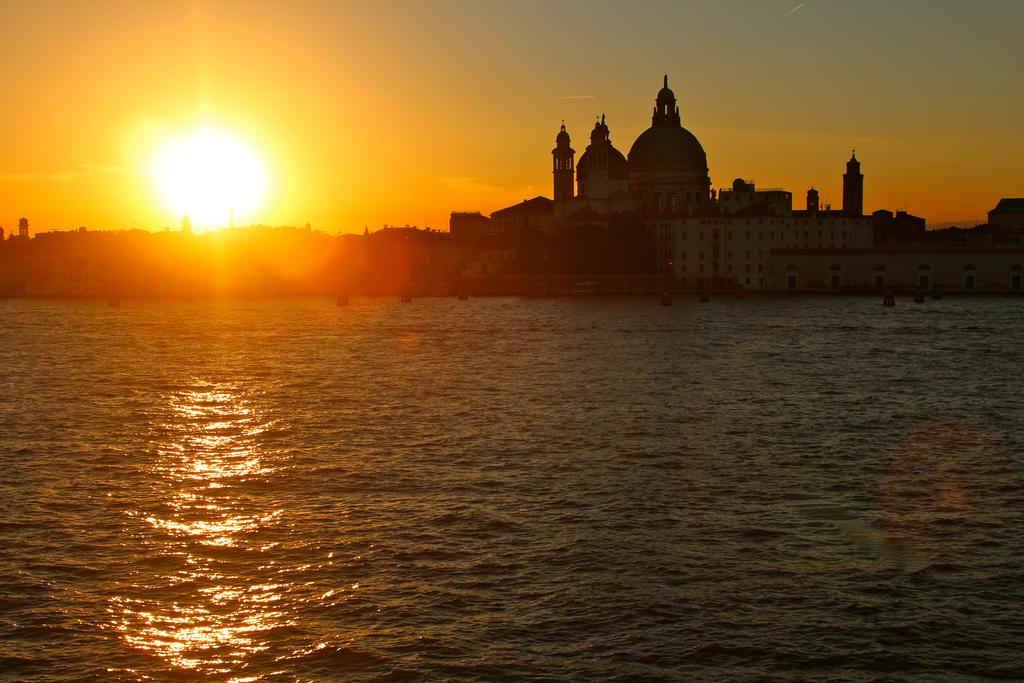What type of natural feature is present in the image? There is a river in the image. What man-made structures can be seen in the image? There are buildings at the center of the image. What celestial event is depicted in the background of the image? There is a sun rising in the background of the image. How many ducks are swimming in the river in the image? There are no ducks present in the image; it only features a river, buildings, and a rising sun. 